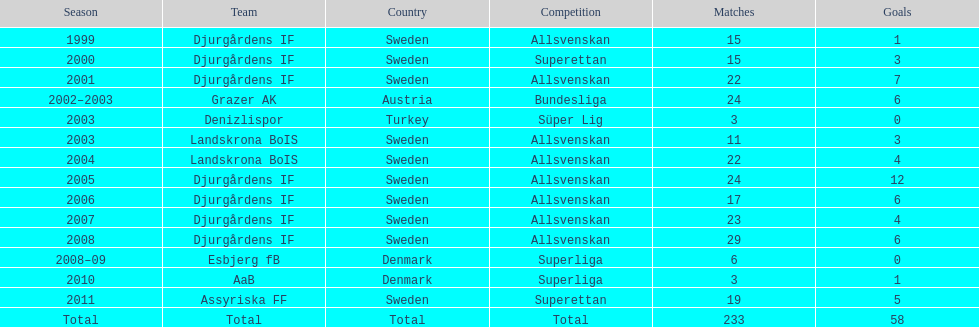During which season do players score the maximum goals? 2005. 